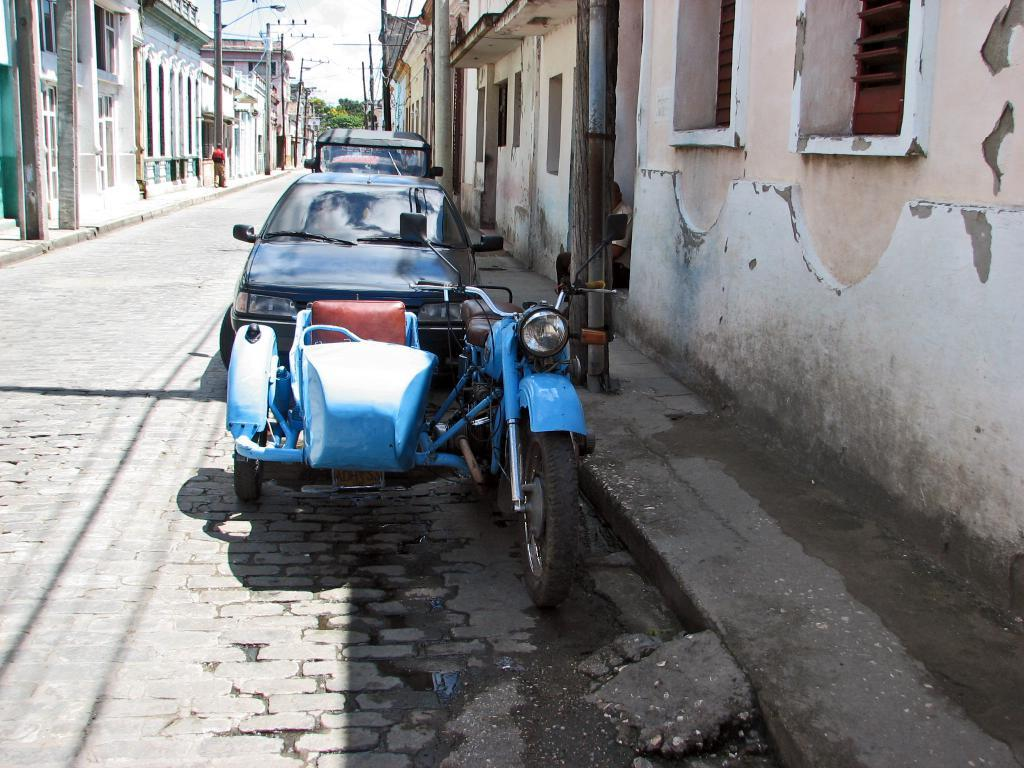What can be seen moving on the road in the image? There are vehicles on the road in the image. What type of structures are present in the image? There are buildings in the image. What type of natural elements can be seen in the image? There are trees in the image. What type of man-made objects are present in the image? There are poles in the image. What type of illumination is present in the image? There are lights in the image. What type of openings can be seen in the buildings in the image? There are windows in the image. Who or what is present in the image? There is a person in the image. What part of the natural environment is visible in the image? The sky is visible in the image. What type of news can be seen being delivered by the person in the image? There is no news being delivered in the image; the person is not holding any newspapers or electronic devices. What type of expression can be seen on the person's face in the image? The person's facial expression cannot be determined from the image. What type of yard is visible in the image? There is no yard visible in the image; the focus is on the road, buildings, and other structures. 